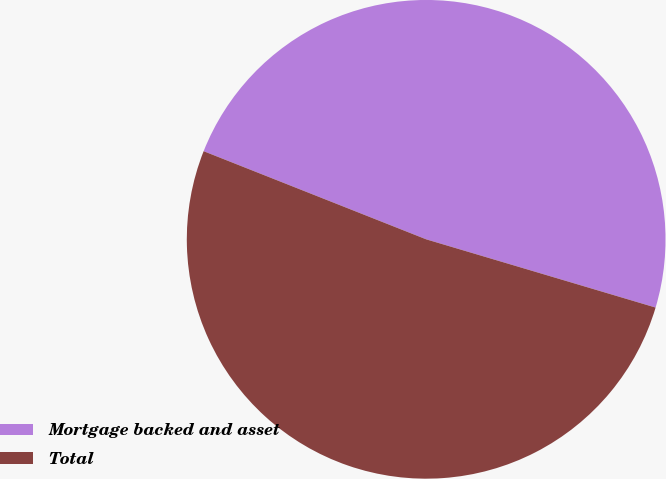Convert chart. <chart><loc_0><loc_0><loc_500><loc_500><pie_chart><fcel>Mortgage backed and asset<fcel>Total<nl><fcel>48.6%<fcel>51.4%<nl></chart> 